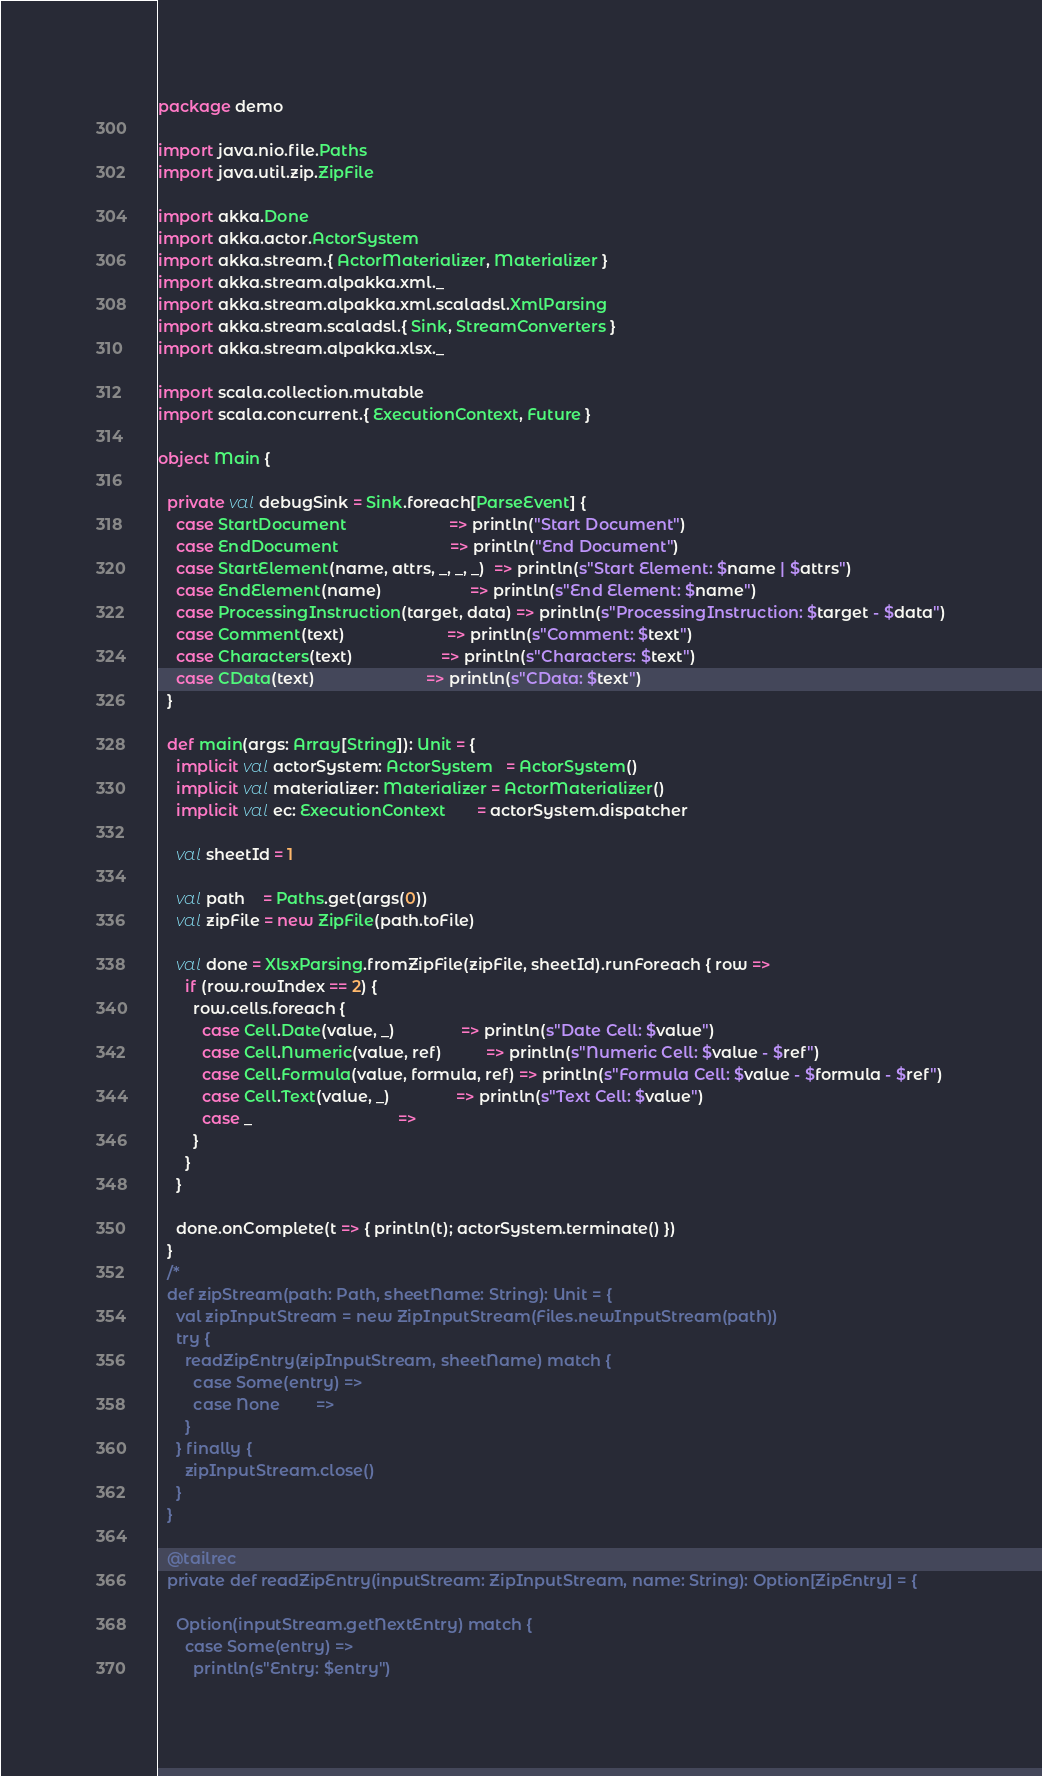<code> <loc_0><loc_0><loc_500><loc_500><_Scala_>package demo

import java.nio.file.Paths
import java.util.zip.ZipFile

import akka.Done
import akka.actor.ActorSystem
import akka.stream.{ ActorMaterializer, Materializer }
import akka.stream.alpakka.xml._
import akka.stream.alpakka.xml.scaladsl.XmlParsing
import akka.stream.scaladsl.{ Sink, StreamConverters }
import akka.stream.alpakka.xlsx._

import scala.collection.mutable
import scala.concurrent.{ ExecutionContext, Future }

object Main {

  private val debugSink = Sink.foreach[ParseEvent] {
    case StartDocument                       => println("Start Document")
    case EndDocument                         => println("End Document")
    case StartElement(name, attrs, _, _, _)  => println(s"Start Element: $name | $attrs")
    case EndElement(name)                    => println(s"End Element: $name")
    case ProcessingInstruction(target, data) => println(s"ProcessingInstruction: $target - $data")
    case Comment(text)                       => println(s"Comment: $text")
    case Characters(text)                    => println(s"Characters: $text")
    case CData(text)                         => println(s"CData: $text")
  }

  def main(args: Array[String]): Unit = {
    implicit val actorSystem: ActorSystem   = ActorSystem()
    implicit val materializer: Materializer = ActorMaterializer()
    implicit val ec: ExecutionContext       = actorSystem.dispatcher

    val sheetId = 1

    val path    = Paths.get(args(0))
    val zipFile = new ZipFile(path.toFile)

    val done = XlsxParsing.fromZipFile(zipFile, sheetId).runForeach { row =>
      if (row.rowIndex == 2) {
        row.cells.foreach {
          case Cell.Date(value, _)               => println(s"Date Cell: $value")
          case Cell.Numeric(value, ref)          => println(s"Numeric Cell: $value - $ref")
          case Cell.Formula(value, formula, ref) => println(s"Formula Cell: $value - $formula - $ref")
          case Cell.Text(value, _)               => println(s"Text Cell: $value")
          case _                                 =>
        }
      }
    }

    done.onComplete(t => { println(t); actorSystem.terminate() })
  }
  /*
  def zipStream(path: Path, sheetName: String): Unit = {
    val zipInputStream = new ZipInputStream(Files.newInputStream(path))
    try {
      readZipEntry(zipInputStream, sheetName) match {
        case Some(entry) =>
        case None        =>
      }
    } finally {
      zipInputStream.close()
    }
  }

  @tailrec
  private def readZipEntry(inputStream: ZipInputStream, name: String): Option[ZipEntry] = {

    Option(inputStream.getNextEntry) match {
      case Some(entry) =>
        println(s"Entry: $entry")</code> 